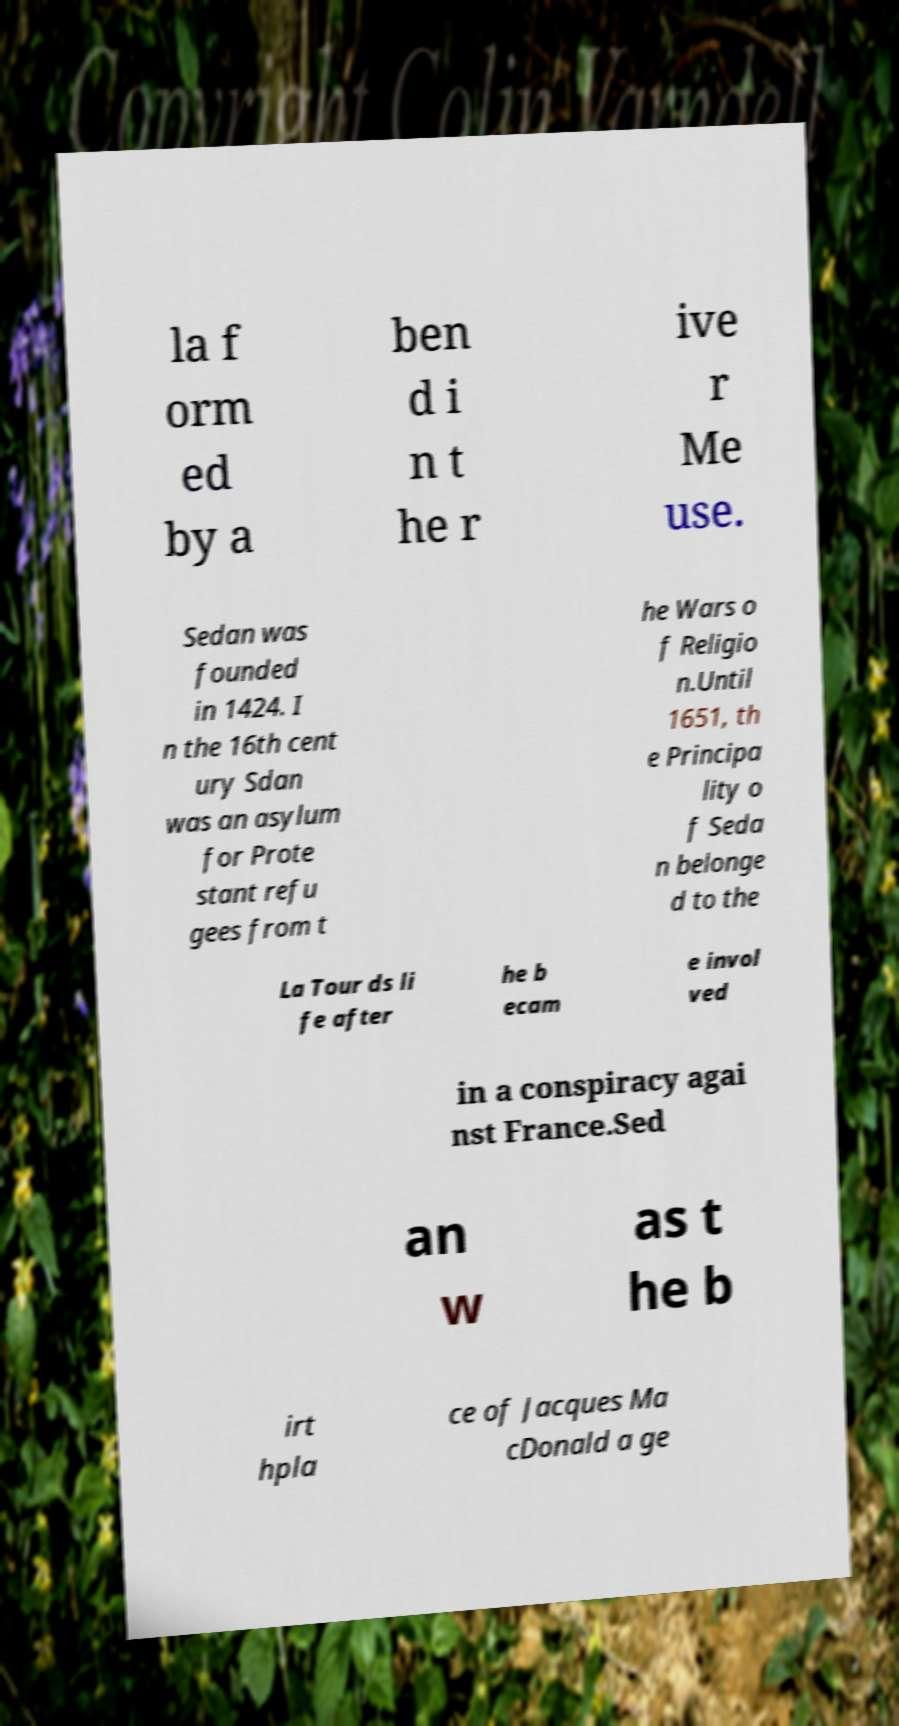What messages or text are displayed in this image? I need them in a readable, typed format. la f orm ed by a ben d i n t he r ive r Me use. Sedan was founded in 1424. I n the 16th cent ury Sdan was an asylum for Prote stant refu gees from t he Wars o f Religio n.Until 1651, th e Principa lity o f Seda n belonge d to the La Tour ds li fe after he b ecam e invol ved in a conspiracy agai nst France.Sed an w as t he b irt hpla ce of Jacques Ma cDonald a ge 